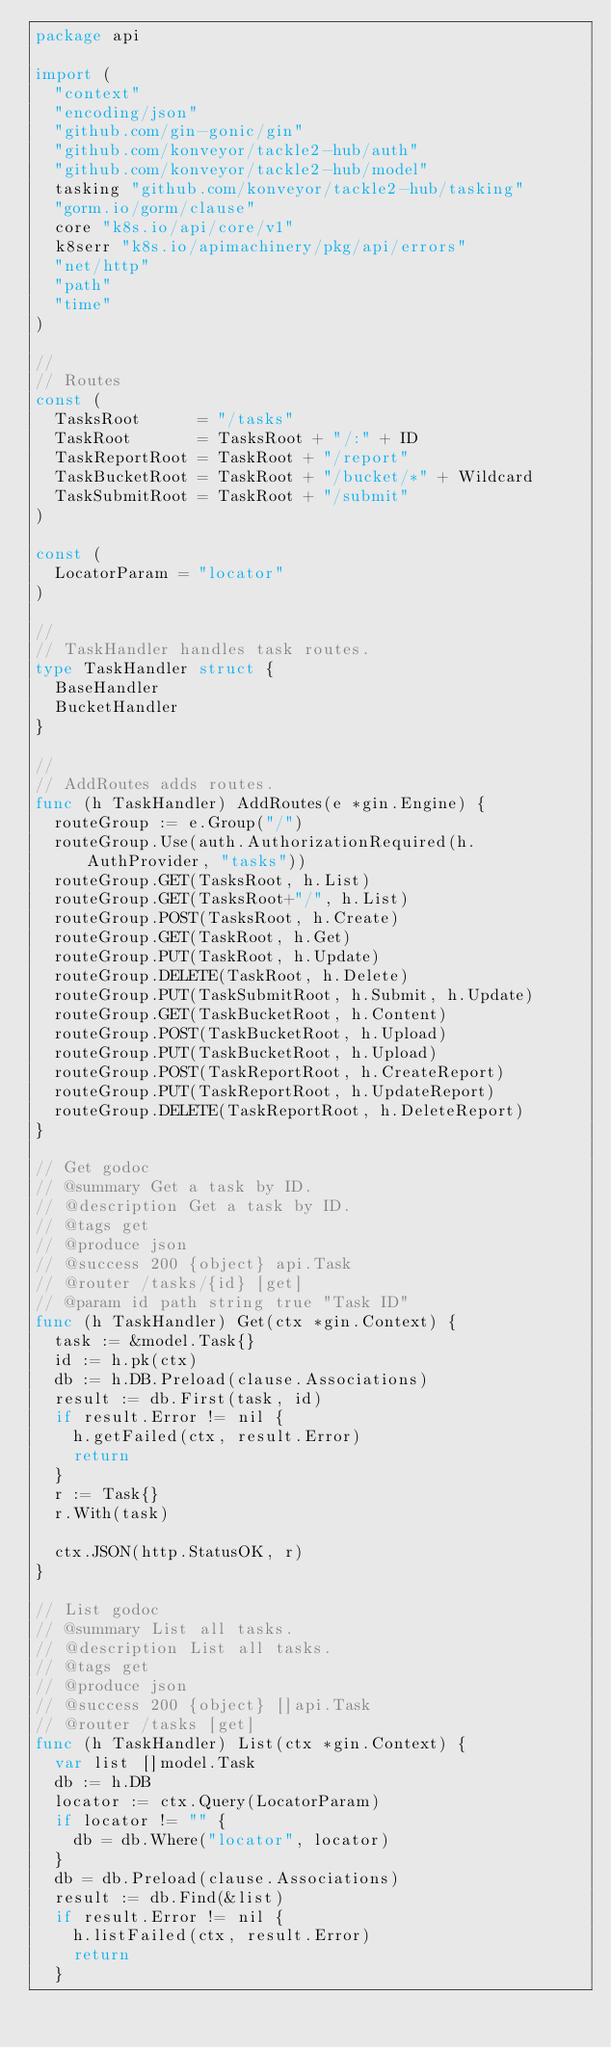Convert code to text. <code><loc_0><loc_0><loc_500><loc_500><_Go_>package api

import (
	"context"
	"encoding/json"
	"github.com/gin-gonic/gin"
	"github.com/konveyor/tackle2-hub/auth"
	"github.com/konveyor/tackle2-hub/model"
	tasking "github.com/konveyor/tackle2-hub/tasking"
	"gorm.io/gorm/clause"
	core "k8s.io/api/core/v1"
	k8serr "k8s.io/apimachinery/pkg/api/errors"
	"net/http"
	"path"
	"time"
)

//
// Routes
const (
	TasksRoot      = "/tasks"
	TaskRoot       = TasksRoot + "/:" + ID
	TaskReportRoot = TaskRoot + "/report"
	TaskBucketRoot = TaskRoot + "/bucket/*" + Wildcard
	TaskSubmitRoot = TaskRoot + "/submit"
)

const (
	LocatorParam = "locator"
)

//
// TaskHandler handles task routes.
type TaskHandler struct {
	BaseHandler
	BucketHandler
}

//
// AddRoutes adds routes.
func (h TaskHandler) AddRoutes(e *gin.Engine) {
	routeGroup := e.Group("/")
	routeGroup.Use(auth.AuthorizationRequired(h.AuthProvider, "tasks"))
	routeGroup.GET(TasksRoot, h.List)
	routeGroup.GET(TasksRoot+"/", h.List)
	routeGroup.POST(TasksRoot, h.Create)
	routeGroup.GET(TaskRoot, h.Get)
	routeGroup.PUT(TaskRoot, h.Update)
	routeGroup.DELETE(TaskRoot, h.Delete)
	routeGroup.PUT(TaskSubmitRoot, h.Submit, h.Update)
	routeGroup.GET(TaskBucketRoot, h.Content)
	routeGroup.POST(TaskBucketRoot, h.Upload)
	routeGroup.PUT(TaskBucketRoot, h.Upload)
	routeGroup.POST(TaskReportRoot, h.CreateReport)
	routeGroup.PUT(TaskReportRoot, h.UpdateReport)
	routeGroup.DELETE(TaskReportRoot, h.DeleteReport)
}

// Get godoc
// @summary Get a task by ID.
// @description Get a task by ID.
// @tags get
// @produce json
// @success 200 {object} api.Task
// @router /tasks/{id} [get]
// @param id path string true "Task ID"
func (h TaskHandler) Get(ctx *gin.Context) {
	task := &model.Task{}
	id := h.pk(ctx)
	db := h.DB.Preload(clause.Associations)
	result := db.First(task, id)
	if result.Error != nil {
		h.getFailed(ctx, result.Error)
		return
	}
	r := Task{}
	r.With(task)

	ctx.JSON(http.StatusOK, r)
}

// List godoc
// @summary List all tasks.
// @description List all tasks.
// @tags get
// @produce json
// @success 200 {object} []api.Task
// @router /tasks [get]
func (h TaskHandler) List(ctx *gin.Context) {
	var list []model.Task
	db := h.DB
	locator := ctx.Query(LocatorParam)
	if locator != "" {
		db = db.Where("locator", locator)
	}
	db = db.Preload(clause.Associations)
	result := db.Find(&list)
	if result.Error != nil {
		h.listFailed(ctx, result.Error)
		return
	}</code> 